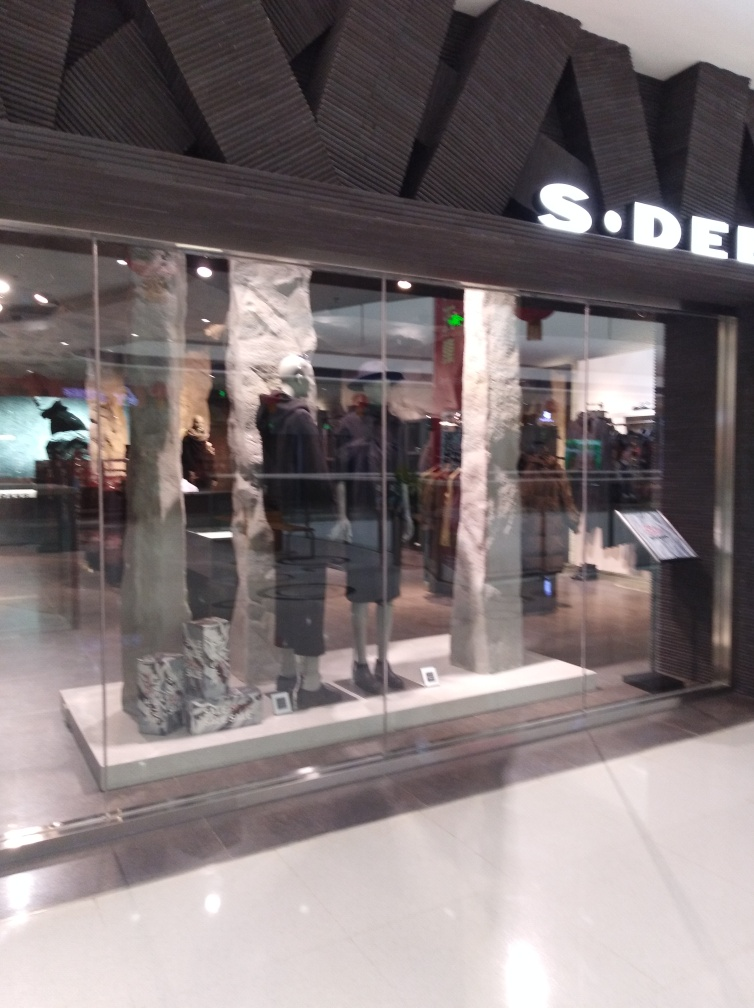Is the text on the storefront clear and visible? While the text is somewhat visible, the likelihood of it being clear is compromised due to reflections and lighting conditions that obscure parts of the storefront text. 